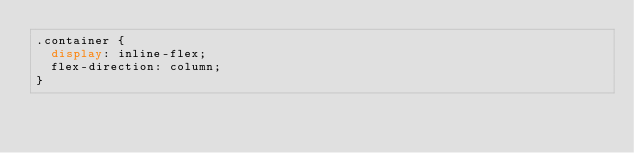<code> <loc_0><loc_0><loc_500><loc_500><_CSS_>.container {
  display: inline-flex;
  flex-direction: column;
}
</code> 